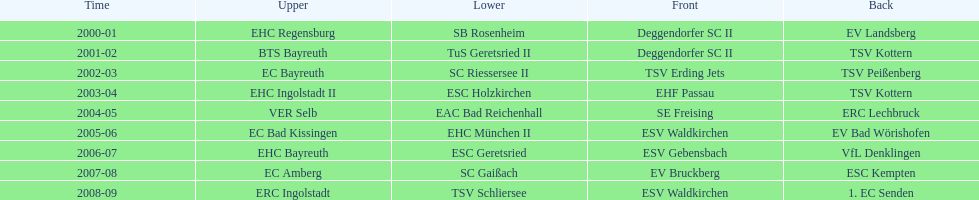Could you parse the entire table? {'header': ['Time', 'Upper', 'Lower', 'Front', 'Back'], 'rows': [['2000-01', 'EHC Regensburg', 'SB Rosenheim', 'Deggendorfer SC II', 'EV Landsberg'], ['2001-02', 'BTS Bayreuth', 'TuS Geretsried II', 'Deggendorfer SC II', 'TSV Kottern'], ['2002-03', 'EC Bayreuth', 'SC Riessersee II', 'TSV Erding Jets', 'TSV Peißenberg'], ['2003-04', 'EHC Ingolstadt II', 'ESC Holzkirchen', 'EHF Passau', 'TSV Kottern'], ['2004-05', 'VER Selb', 'EAC Bad Reichenhall', 'SE Freising', 'ERC Lechbruck'], ['2005-06', 'EC Bad Kissingen', 'EHC München II', 'ESV Waldkirchen', 'EV Bad Wörishofen'], ['2006-07', 'EHC Bayreuth', 'ESC Geretsried', 'ESV Gebensbach', 'VfL Denklingen'], ['2007-08', 'EC Amberg', 'SC Gaißach', 'EV Bruckberg', 'ESC Kempten'], ['2008-09', 'ERC Ingolstadt', 'TSV Schliersee', 'ESV Waldkirchen', '1. EC Senden']]} Which name appears more often, kottern or bayreuth? Bayreuth. 